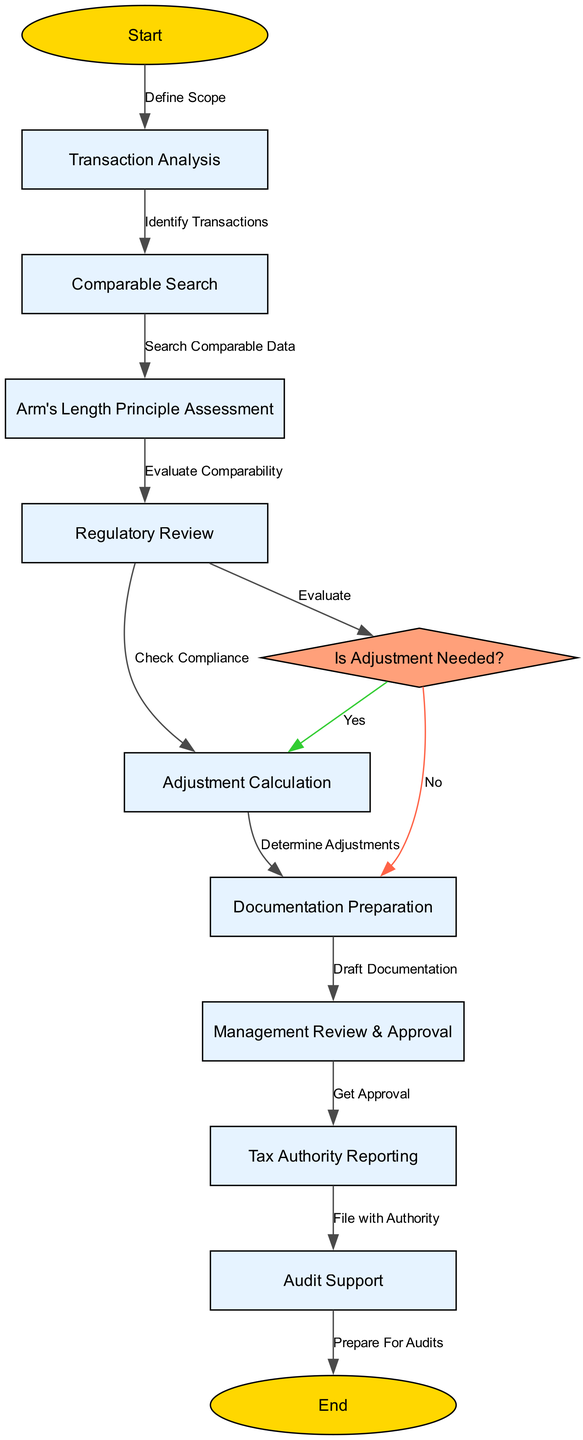What is the first step in the transfer pricing adjustment process? The first step in the process is "Start," followed by the action "Define Scope" which leads to "Transaction Analysis."
Answer: Transaction Analysis How many decision points are present in the diagram? There is one decision point labeled "Is Adjustment Needed?" that evaluates whether an adjustment is needed before proceeding further.
Answer: One What is the last step before reaching the end of the process? The last step before reaching "End" is "Prepare For Audits," which is the concluding action after filing with the tax authority.
Answer: Prepare For Audits What is the relationship between "Regulatory Review" and "Adjustment Calculation"? After completing "Regulatory Review," the process checks compliance before moving to "Adjustment Calculation."
Answer: Check Compliance If an adjustment is not needed, what is the next step in the process? If an adjustment is not needed, it proceeds to "Documentation Preparation," following the evaluation of whether an adjustment is required.
Answer: Documentation Preparation Which step follows after the "Management Review & Approval"? Following "Management Review & Approval," the next step is "Tax Authority Reporting," where documentation is submitted to the relevant authority.
Answer: Tax Authority Reporting What step involves determining adjustments? The step for determining adjustments comes after "Regulatory Review" and proceeds to "Adjustment Calculation."
Answer: Adjustment Calculation What color represents the decision point in the diagram? The decision point, which evaluates whether an adjustment is needed, is represented in light coral or salmon color, indicating its unique role in the process.
Answer: Light Coral How are the edges labeled in the diagram? The edges, which connect the nodes and indicate the flow of actions, are labeled with the specific relationship or action linking those steps together.
Answer: Labeled with actions 